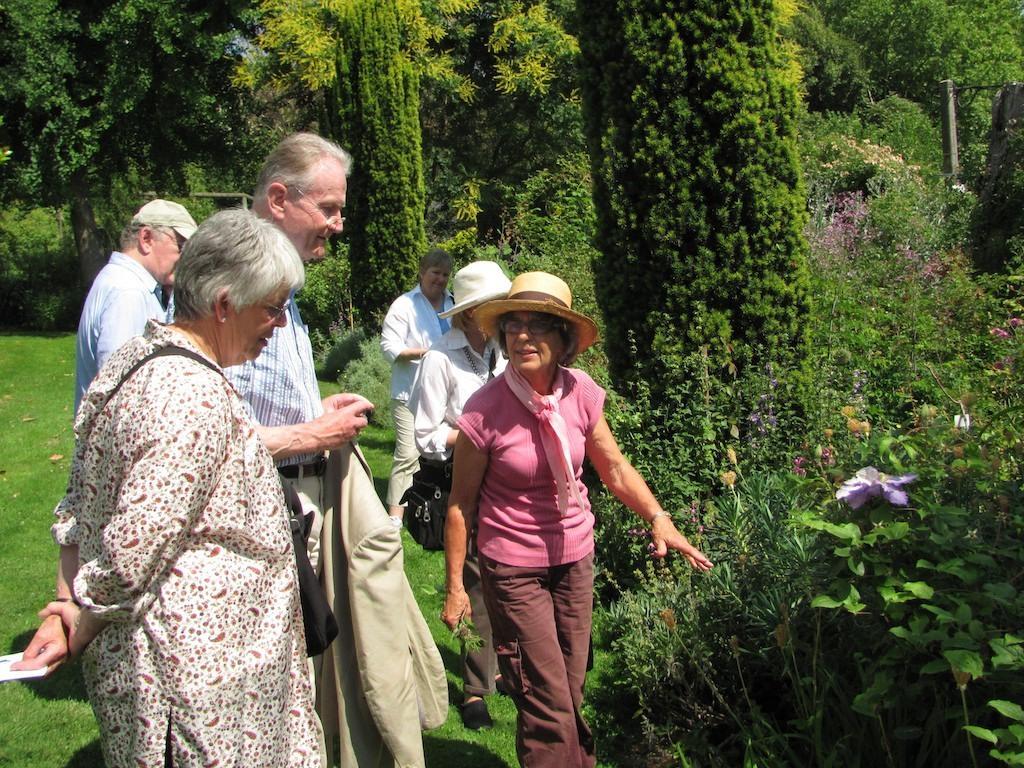Please provide a concise description of this image. In this image there are a few people standing on the surface of the grass, one of them is holding his coat in his hand and few are wearing hats on their heads. In the background there are trees, plants and flowers. 